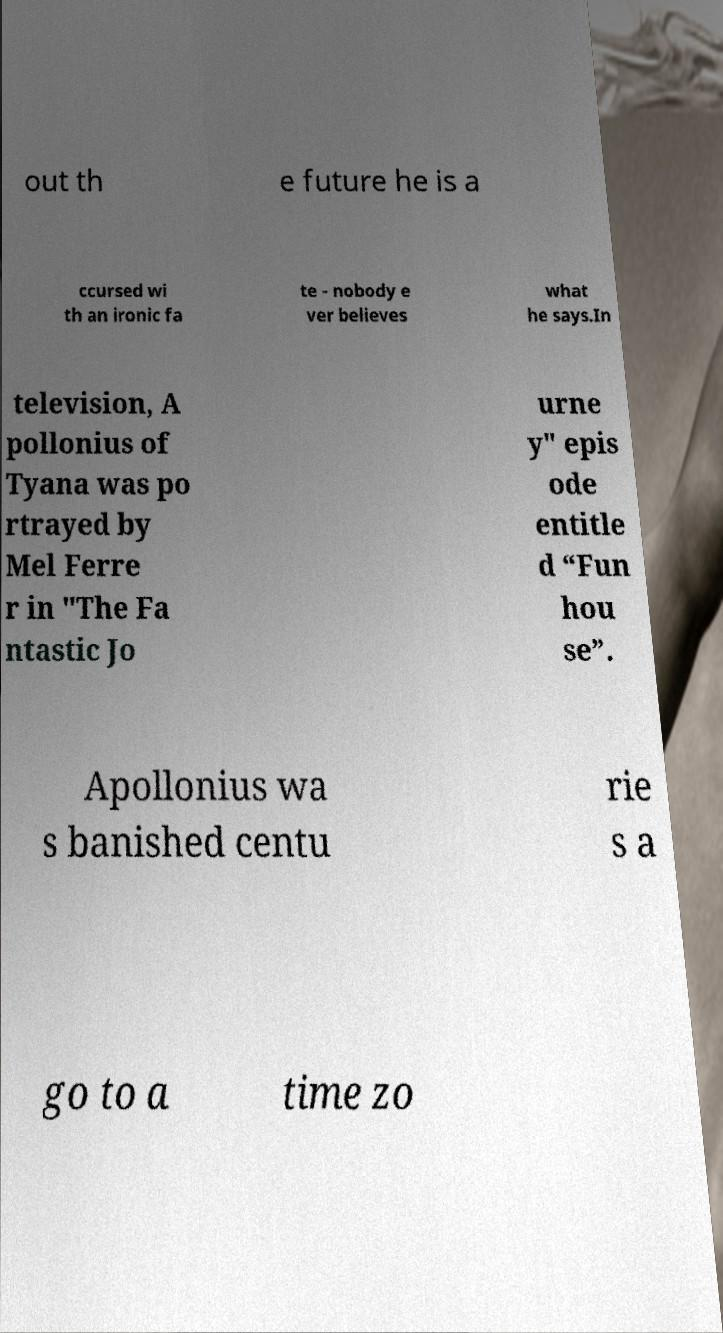Could you extract and type out the text from this image? out th e future he is a ccursed wi th an ironic fa te - nobody e ver believes what he says.In television, A pollonius of Tyana was po rtrayed by Mel Ferre r in "The Fa ntastic Jo urne y" epis ode entitle d “Fun hou se”. Apollonius wa s banished centu rie s a go to a time zo 